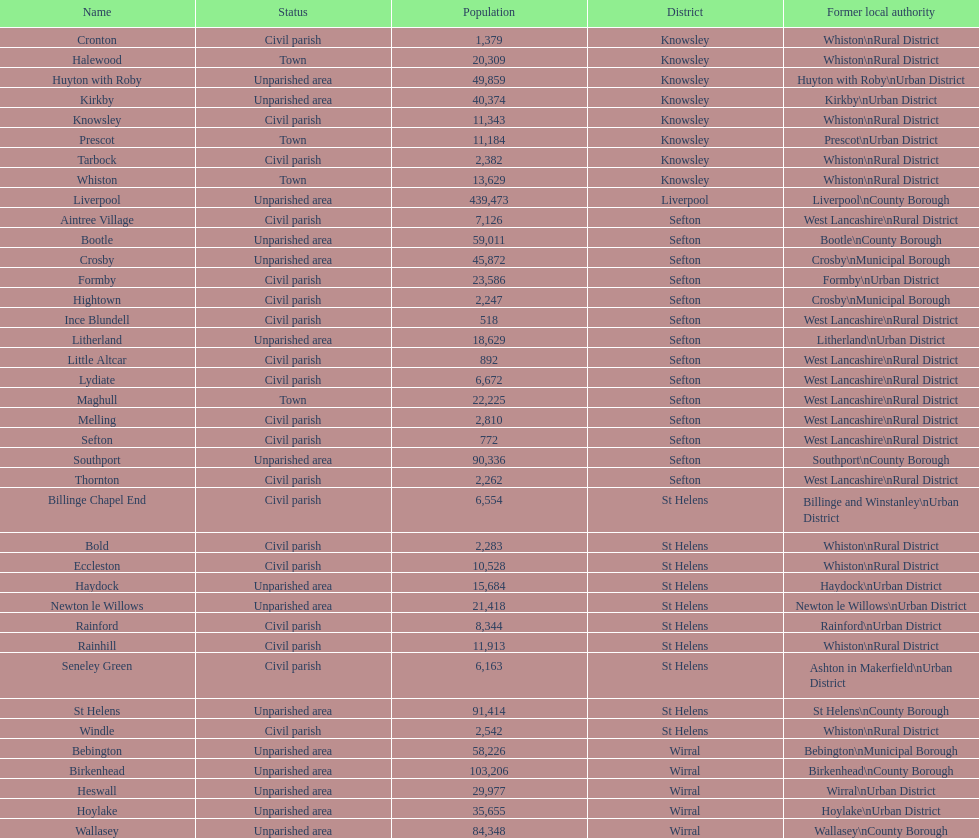Is a civil parish found in aintree village or maghull? Aintree Village. 